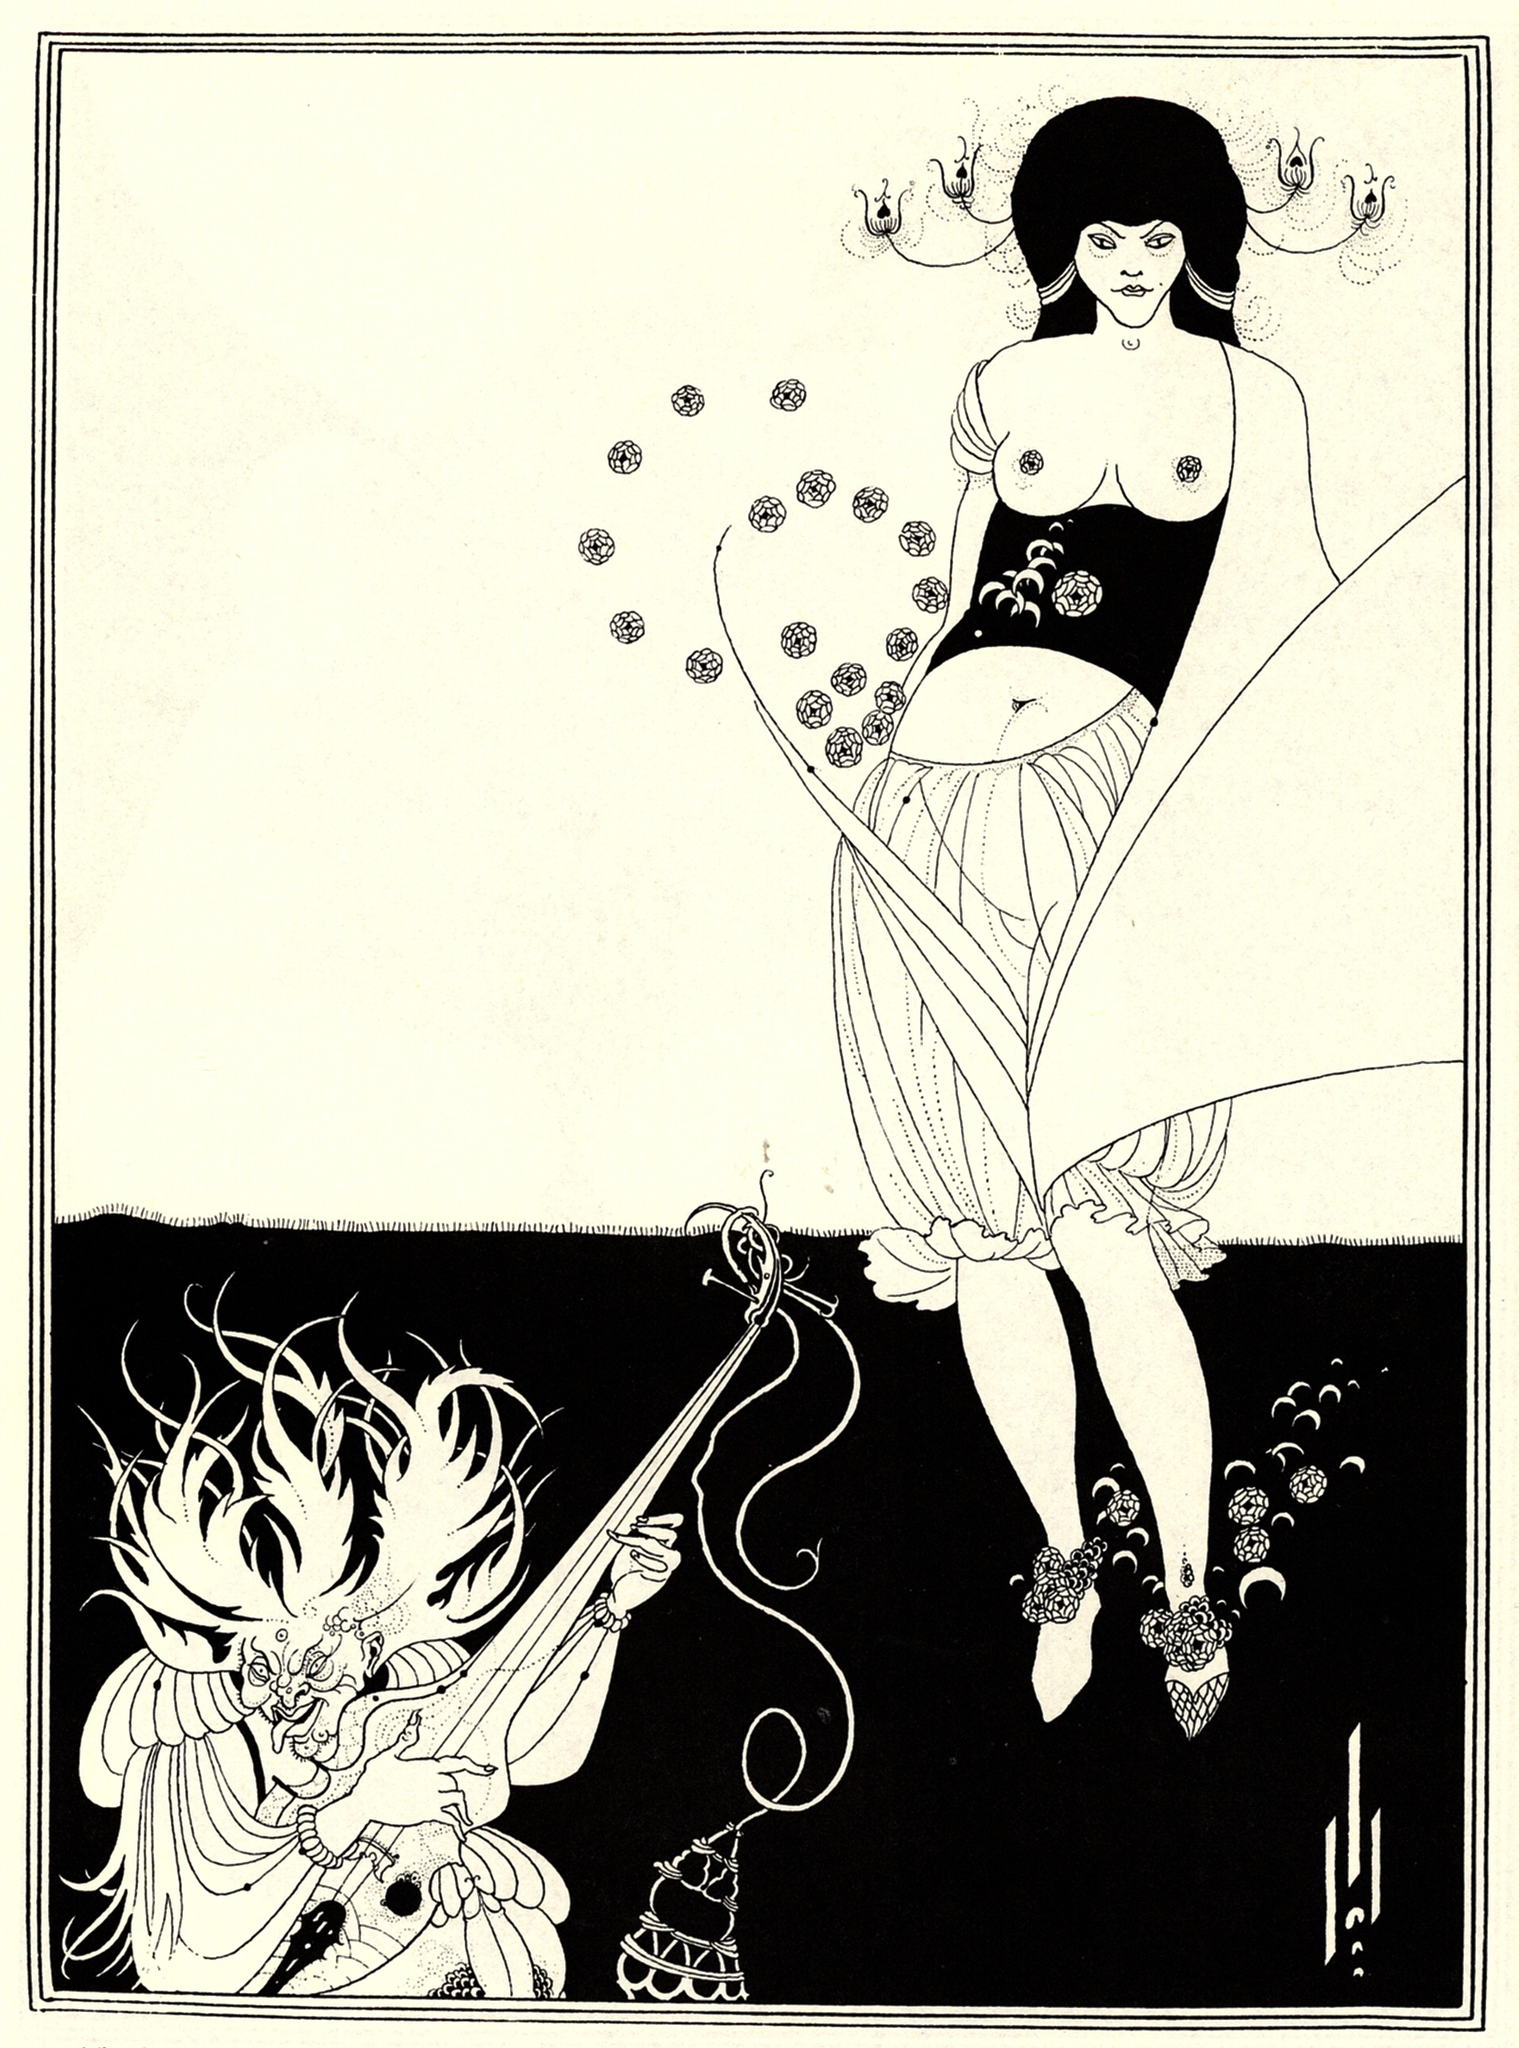What's the significance of the patterns and designs present in the illustration? The patterns and designs in the illustration are not merely decorative but serve to enhance the thematic and aesthetic coherence of the artwork. The floral motifs on the woman's dress highlight the connection to nature and the Art Nouveau style's emphasis on natural forms. These patterns could symbolize growth, femininity, and the cyclical nature of life.

Similarly, the intricate designs on the dragon's body may represent its mystical and ancient qualities, embedding it with a sense of timelessness and power. The harmonious yet contrasting elements of the floral patterns between the woman and the dragon unify the composition, suggesting an underlying connection despite their apparent differences. This artistic choice emphasizes the intertwined fates or destinies of the characters, adding depth to the visual narrative. 